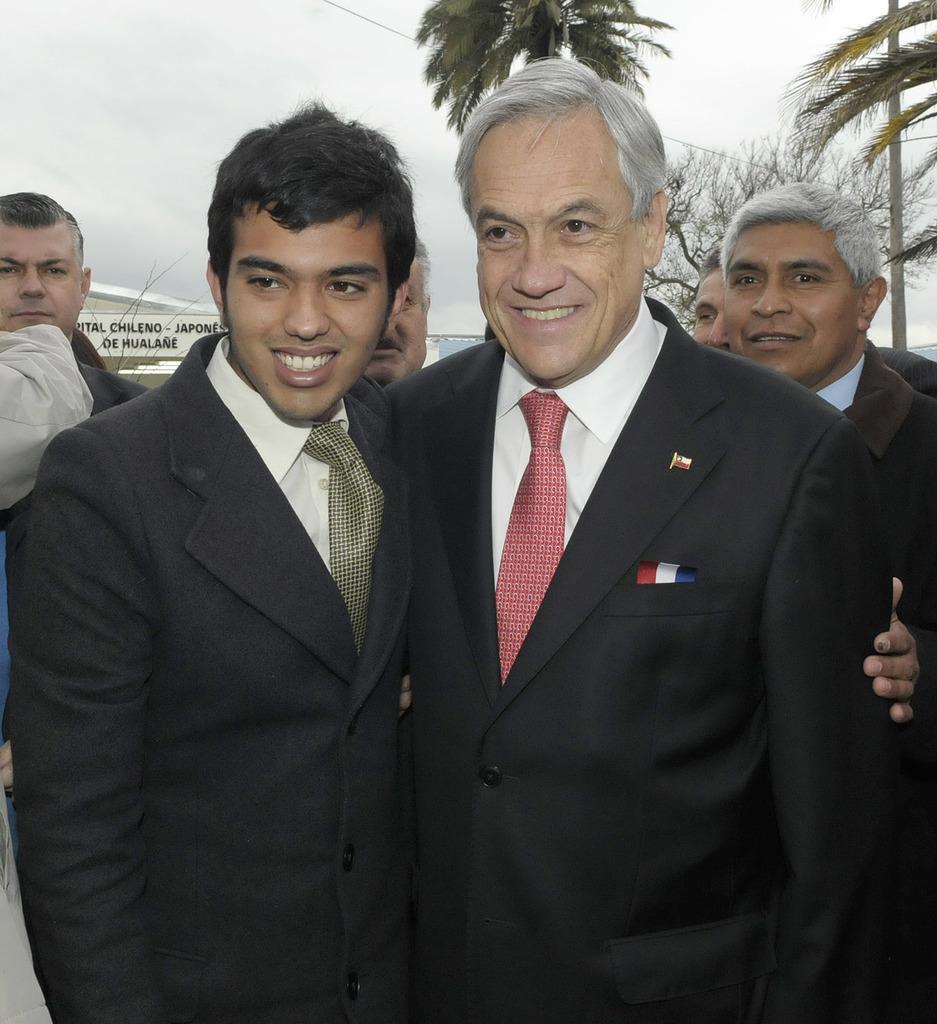Describe this image in one or two sentences. In this picture we can see two people are standing and smiling. We can see some people, board, wire and trees in the background. 